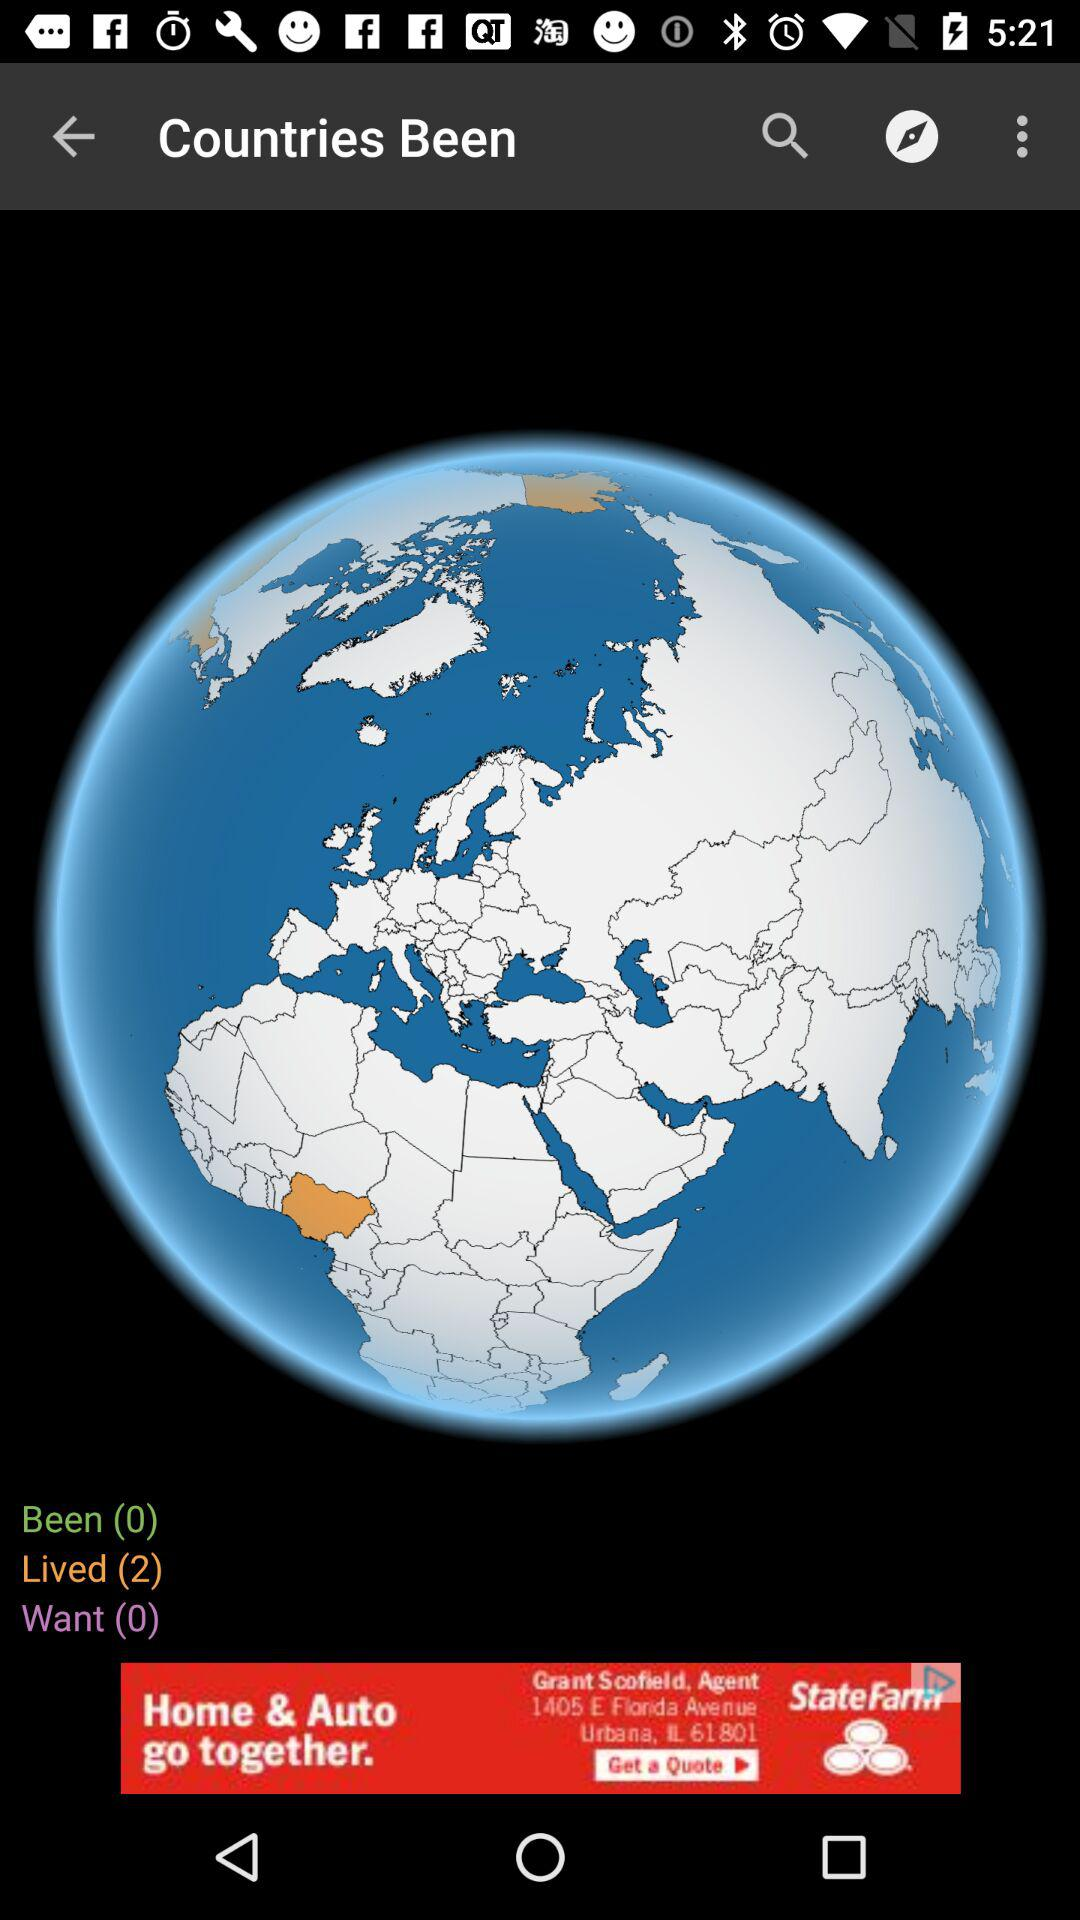What is the count of "Lived"? The count is 2. 